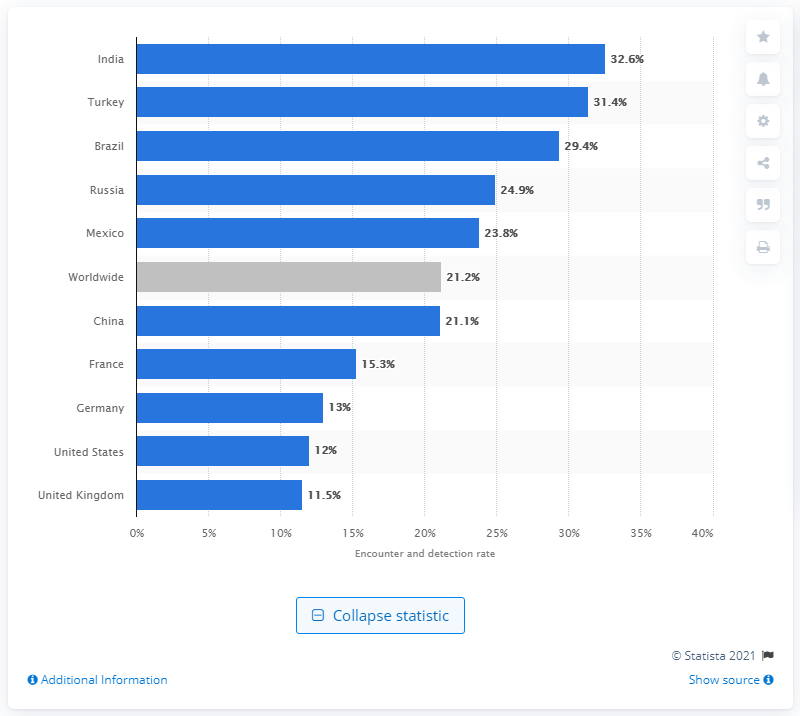Highlight a few significant elements in this photo. During the second quarter of 2016, 29.4% of Microsoft computers in Brazil detected malware threats. 